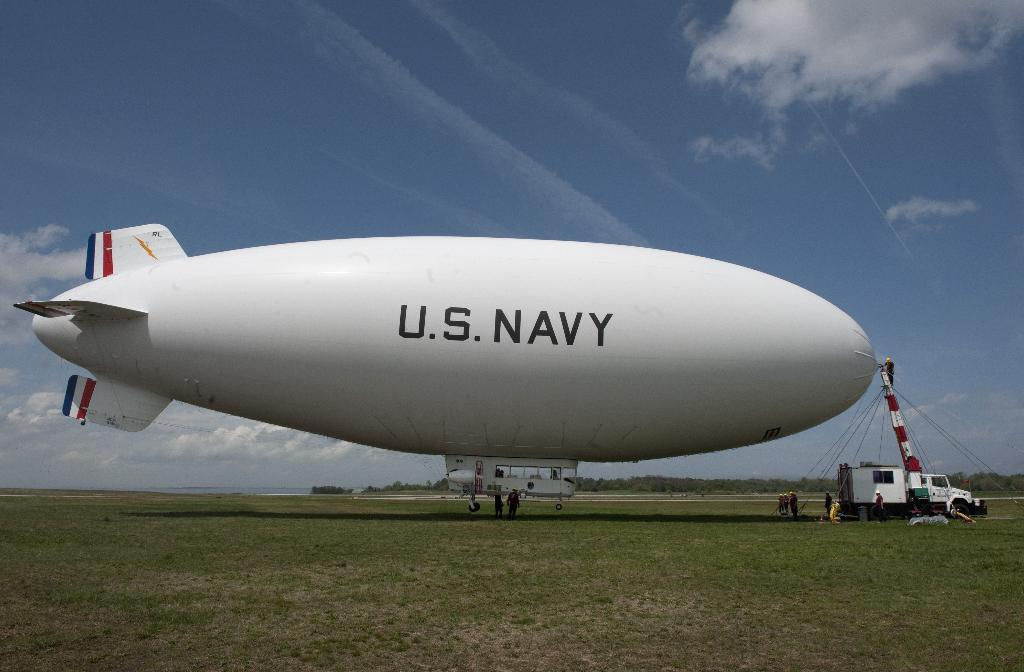<image>
Describe the image concisely. A U.S. Navy blimp is sitting in the middle of the field. 